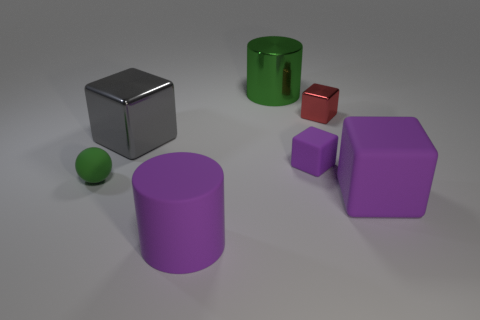There is a metal cube that is the same size as the green metal object; what color is it?
Your response must be concise. Gray. Are there any small objects that have the same color as the big metal cylinder?
Give a very brief answer. Yes. Are there fewer large purple matte cubes behind the large green cylinder than big cylinders in front of the large purple rubber cube?
Offer a very short reply. Yes. What is the material of the tiny object that is both to the left of the tiny metallic object and on the right side of the tiny green object?
Offer a very short reply. Rubber. Does the large gray metallic object have the same shape as the shiny object that is to the right of the green metal thing?
Provide a short and direct response. Yes. What number of other things are the same size as the gray object?
Give a very brief answer. 3. Are there more purple rubber things than objects?
Provide a short and direct response. No. What number of purple objects are in front of the green rubber sphere and on the left side of the small red metallic thing?
Your answer should be very brief. 1. What shape is the small thing behind the small rubber thing on the right side of the large cylinder in front of the red block?
Offer a very short reply. Cube. Are there any other things that are the same shape as the tiny purple thing?
Offer a very short reply. Yes. 